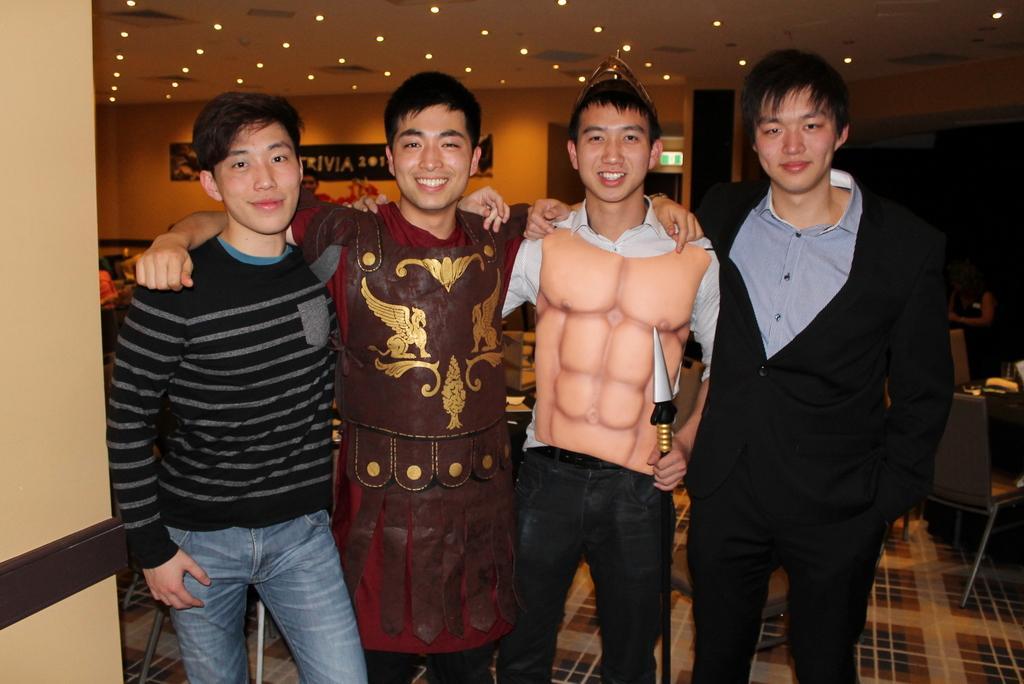Can you describe this image briefly? In this image I can see on the right side a man is standing, he wore black color coat. Beside him another man is standing, he wore fake six pack plastic thing. Beside him another man is standing and smiling, he wore brown color thing, on the left side a man wore black color sweater, at the top there are ceiling lights on the right side there are chairs in this image. 